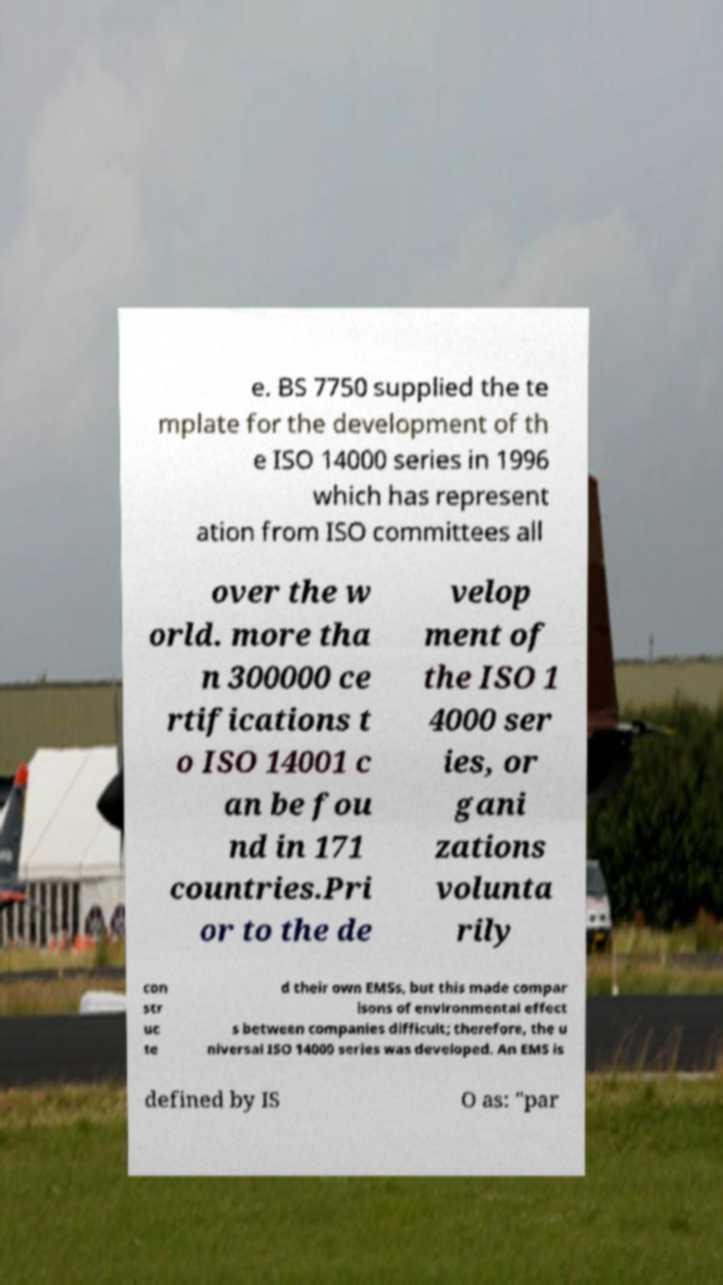Can you accurately transcribe the text from the provided image for me? e. BS 7750 supplied the te mplate for the development of th e ISO 14000 series in 1996 which has represent ation from ISO committees all over the w orld. more tha n 300000 ce rtifications t o ISO 14001 c an be fou nd in 171 countries.Pri or to the de velop ment of the ISO 1 4000 ser ies, or gani zations volunta rily con str uc te d their own EMSs, but this made compar isons of environmental effect s between companies difficult; therefore, the u niversal ISO 14000 series was developed. An EMS is defined by IS O as: "par 